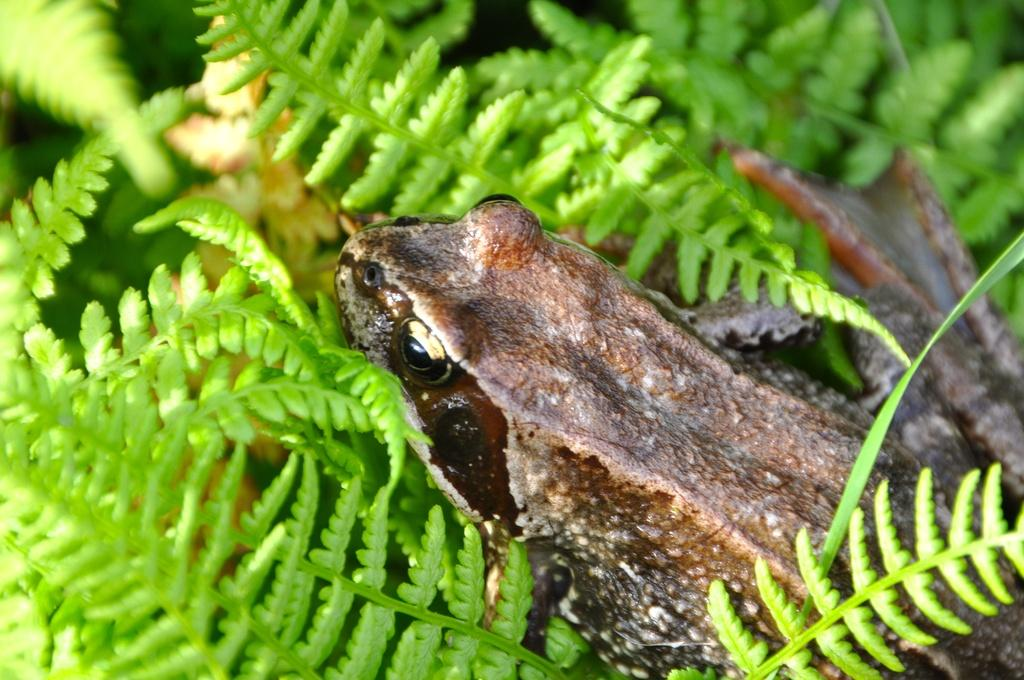What type of animal is present in the image? There is a frog in the image. What can be seen in the background of the image? There are leaves visible in the background of the image. What type of hook is the frog using to climb the glass in the image? There is no hook or glass present in the image; it features a frog and leaves in the background. 